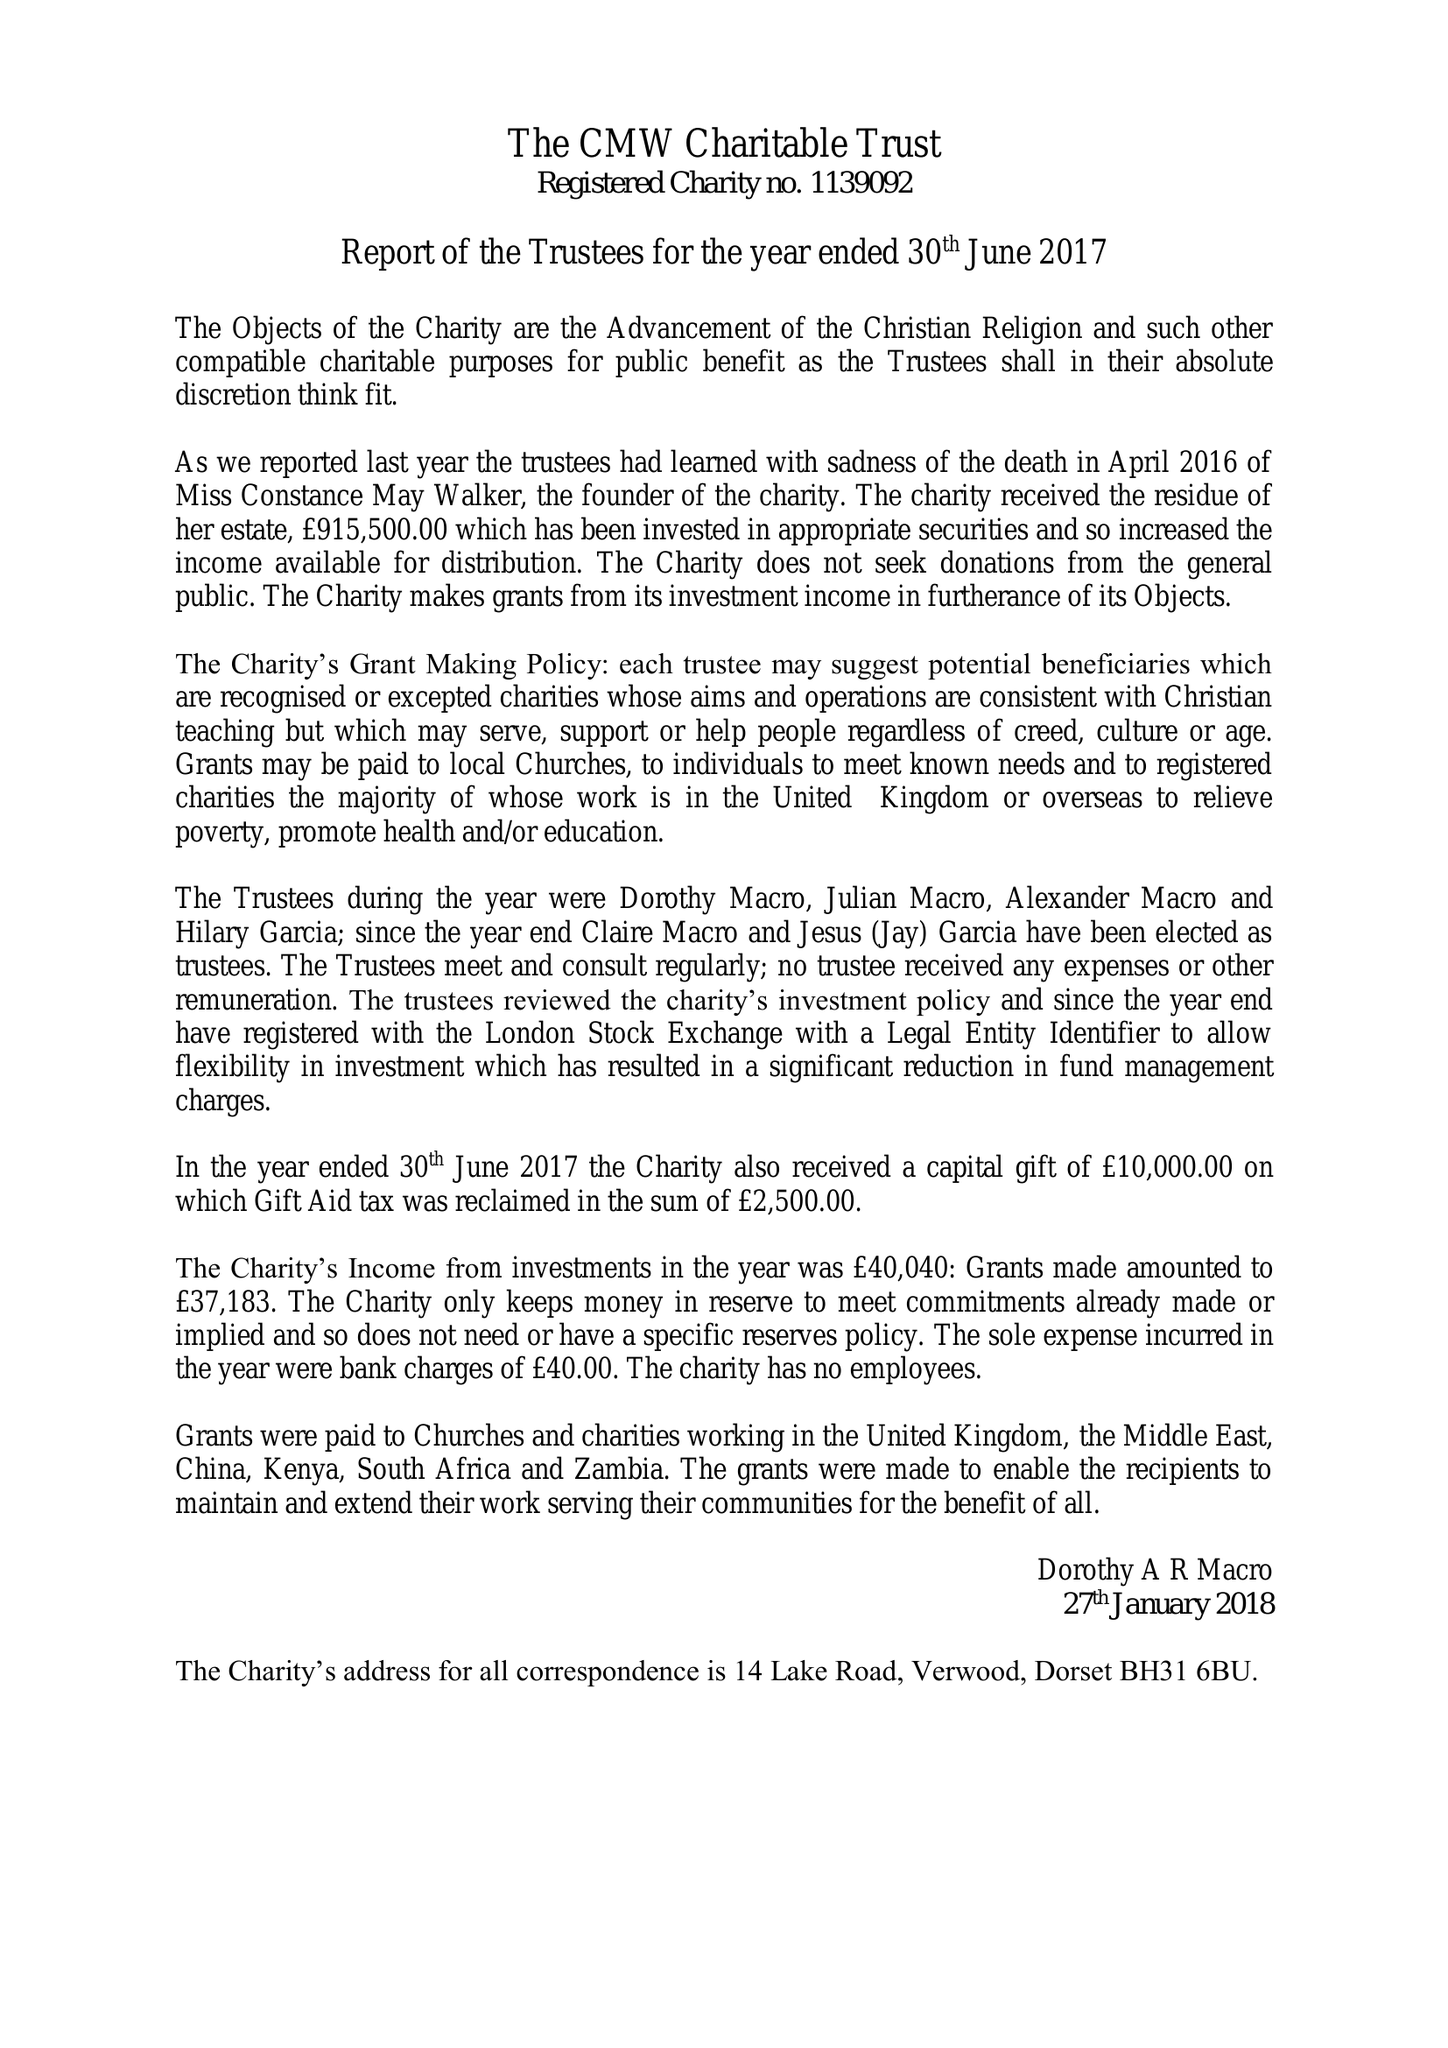What is the value for the address__postcode?
Answer the question using a single word or phrase. BH31 6BU 